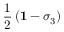<formula> <loc_0><loc_0><loc_500><loc_500>\frac { 1 } { 2 } \left ( { 1 } - \sigma _ { 3 } \right )</formula> 